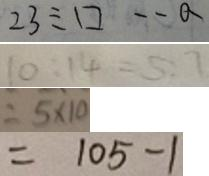<formula> <loc_0><loc_0><loc_500><loc_500>2 3 \div \square \cdot a 
 1 0 : 1 4 = 5 : 7 
 = 5 \times 1 0 
 = 1 0 5 - 1</formula> 